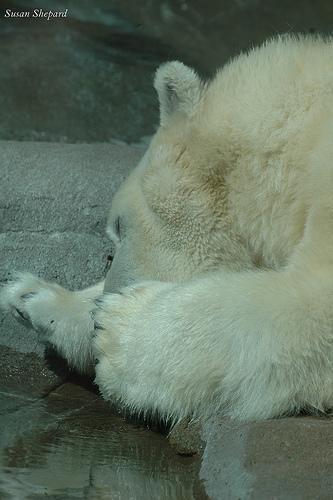How many paws are visible in the picture?
Give a very brief answer. 2. 